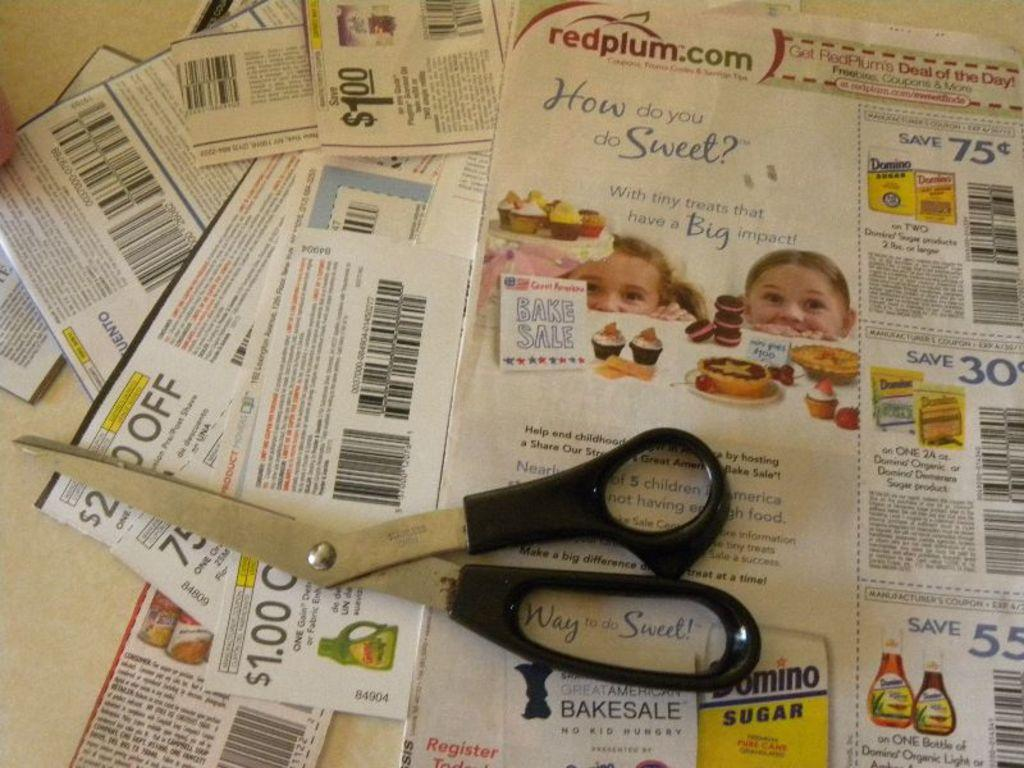What object is present in the image that is used for cutting? There is a scissors in the image that is used for cutting. Where is the scissors located in the image? The scissors are on a table in the image. What other office supply items can be seen in the image? There are paper clips in the image. Where are the paper clips located in the image? The paper clips are on a table in the image. What type of honey is being used to stick the paper clips together in the image? There is no honey present in the image, and the paper clips are not being stuck together. 